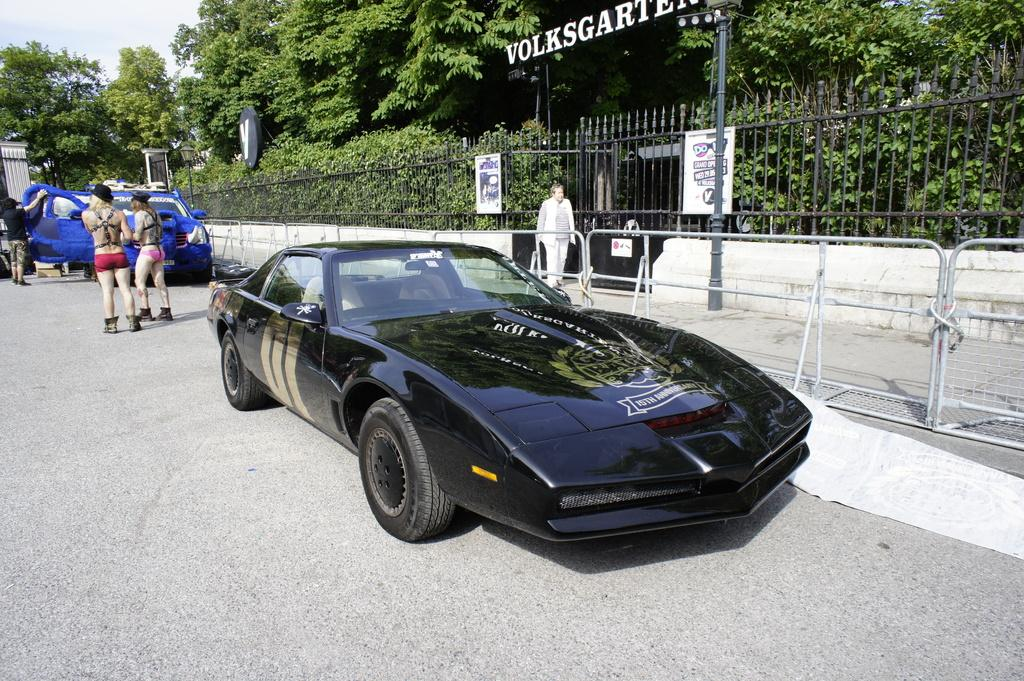How many cars are in the image? There are two cars in the image. What else can be seen in the image besides the cars? There are two women standing and a man walking on a walkway in the image. What is visible in the background of the image? Trees are visible in the background of the image. What is the condition of the sky in the image? The sky is clear in the image. Can you touch the grass in the image? There is no grass present in the image, so it cannot be touched. What type of amusement park can be seen in the image? There is no amusement park present in the image. 